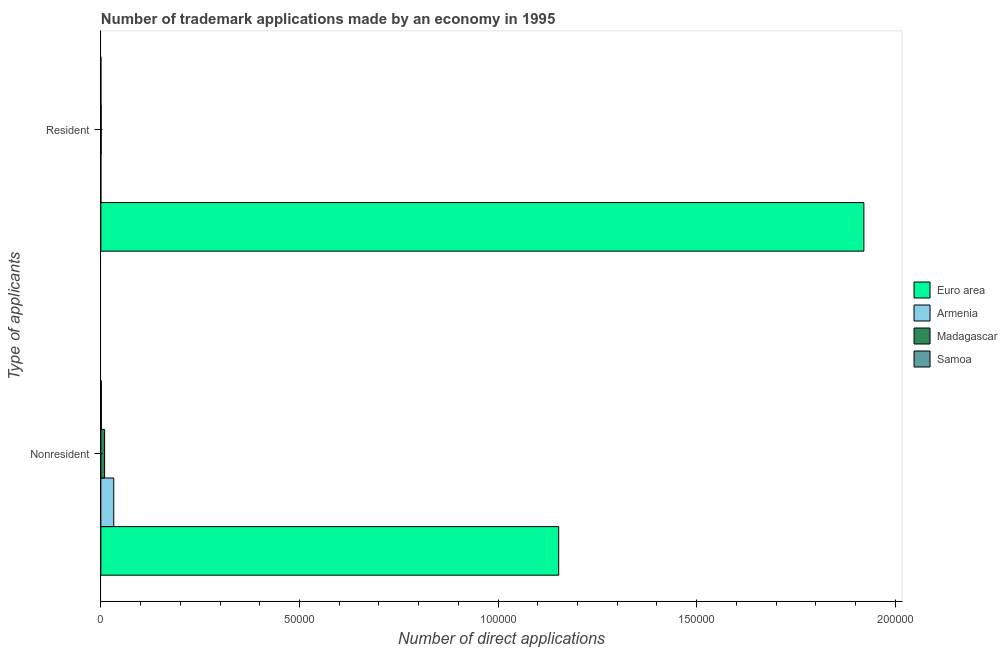Are the number of bars per tick equal to the number of legend labels?
Your response must be concise. Yes. How many bars are there on the 1st tick from the top?
Keep it short and to the point. 4. What is the label of the 2nd group of bars from the top?
Ensure brevity in your answer.  Nonresident. What is the number of trademark applications made by residents in Euro area?
Your answer should be very brief. 1.92e+05. Across all countries, what is the maximum number of trademark applications made by non residents?
Your answer should be very brief. 1.15e+05. Across all countries, what is the minimum number of trademark applications made by non residents?
Provide a short and direct response. 132. In which country was the number of trademark applications made by non residents maximum?
Your answer should be very brief. Euro area. In which country was the number of trademark applications made by residents minimum?
Provide a succinct answer. Armenia. What is the total number of trademark applications made by residents in the graph?
Offer a very short reply. 1.92e+05. What is the difference between the number of trademark applications made by non residents in Armenia and that in Madagascar?
Ensure brevity in your answer.  2294. What is the difference between the number of trademark applications made by residents in Madagascar and the number of trademark applications made by non residents in Samoa?
Give a very brief answer. -38. What is the average number of trademark applications made by non residents per country?
Keep it short and to the point. 2.99e+04. What is the difference between the number of trademark applications made by non residents and number of trademark applications made by residents in Samoa?
Make the answer very short. 120. In how many countries, is the number of trademark applications made by non residents greater than 30000 ?
Give a very brief answer. 1. What is the ratio of the number of trademark applications made by residents in Madagascar to that in Armenia?
Offer a terse response. 15.67. What does the 4th bar from the bottom in Nonresident represents?
Provide a succinct answer. Samoa. How many bars are there?
Offer a terse response. 8. Are all the bars in the graph horizontal?
Offer a terse response. Yes. How many countries are there in the graph?
Give a very brief answer. 4. What is the difference between two consecutive major ticks on the X-axis?
Offer a terse response. 5.00e+04. Where does the legend appear in the graph?
Your answer should be compact. Center right. How are the legend labels stacked?
Keep it short and to the point. Vertical. What is the title of the graph?
Keep it short and to the point. Number of trademark applications made by an economy in 1995. Does "Austria" appear as one of the legend labels in the graph?
Keep it short and to the point. No. What is the label or title of the X-axis?
Give a very brief answer. Number of direct applications. What is the label or title of the Y-axis?
Your answer should be very brief. Type of applicants. What is the Number of direct applications of Euro area in Nonresident?
Your answer should be very brief. 1.15e+05. What is the Number of direct applications in Armenia in Nonresident?
Keep it short and to the point. 3248. What is the Number of direct applications in Madagascar in Nonresident?
Ensure brevity in your answer.  954. What is the Number of direct applications in Samoa in Nonresident?
Provide a succinct answer. 132. What is the Number of direct applications of Euro area in Resident?
Give a very brief answer. 1.92e+05. What is the Number of direct applications in Armenia in Resident?
Your answer should be compact. 6. What is the Number of direct applications of Madagascar in Resident?
Your answer should be very brief. 94. What is the Number of direct applications in Samoa in Resident?
Make the answer very short. 12. Across all Type of applicants, what is the maximum Number of direct applications of Euro area?
Your answer should be compact. 1.92e+05. Across all Type of applicants, what is the maximum Number of direct applications in Armenia?
Provide a short and direct response. 3248. Across all Type of applicants, what is the maximum Number of direct applications of Madagascar?
Offer a very short reply. 954. Across all Type of applicants, what is the maximum Number of direct applications of Samoa?
Keep it short and to the point. 132. Across all Type of applicants, what is the minimum Number of direct applications of Euro area?
Give a very brief answer. 1.15e+05. Across all Type of applicants, what is the minimum Number of direct applications of Armenia?
Make the answer very short. 6. Across all Type of applicants, what is the minimum Number of direct applications of Madagascar?
Give a very brief answer. 94. What is the total Number of direct applications of Euro area in the graph?
Your answer should be compact. 3.07e+05. What is the total Number of direct applications in Armenia in the graph?
Give a very brief answer. 3254. What is the total Number of direct applications in Madagascar in the graph?
Offer a very short reply. 1048. What is the total Number of direct applications in Samoa in the graph?
Your answer should be very brief. 144. What is the difference between the Number of direct applications in Euro area in Nonresident and that in Resident?
Offer a very short reply. -7.68e+04. What is the difference between the Number of direct applications of Armenia in Nonresident and that in Resident?
Make the answer very short. 3242. What is the difference between the Number of direct applications of Madagascar in Nonresident and that in Resident?
Give a very brief answer. 860. What is the difference between the Number of direct applications of Samoa in Nonresident and that in Resident?
Your response must be concise. 120. What is the difference between the Number of direct applications in Euro area in Nonresident and the Number of direct applications in Armenia in Resident?
Provide a succinct answer. 1.15e+05. What is the difference between the Number of direct applications of Euro area in Nonresident and the Number of direct applications of Madagascar in Resident?
Provide a short and direct response. 1.15e+05. What is the difference between the Number of direct applications of Euro area in Nonresident and the Number of direct applications of Samoa in Resident?
Provide a succinct answer. 1.15e+05. What is the difference between the Number of direct applications of Armenia in Nonresident and the Number of direct applications of Madagascar in Resident?
Offer a terse response. 3154. What is the difference between the Number of direct applications of Armenia in Nonresident and the Number of direct applications of Samoa in Resident?
Provide a succinct answer. 3236. What is the difference between the Number of direct applications of Madagascar in Nonresident and the Number of direct applications of Samoa in Resident?
Ensure brevity in your answer.  942. What is the average Number of direct applications in Euro area per Type of applicants?
Give a very brief answer. 1.54e+05. What is the average Number of direct applications in Armenia per Type of applicants?
Provide a succinct answer. 1627. What is the average Number of direct applications in Madagascar per Type of applicants?
Give a very brief answer. 524. What is the average Number of direct applications of Samoa per Type of applicants?
Provide a short and direct response. 72. What is the difference between the Number of direct applications in Euro area and Number of direct applications in Armenia in Nonresident?
Your response must be concise. 1.12e+05. What is the difference between the Number of direct applications of Euro area and Number of direct applications of Madagascar in Nonresident?
Provide a short and direct response. 1.14e+05. What is the difference between the Number of direct applications in Euro area and Number of direct applications in Samoa in Nonresident?
Your response must be concise. 1.15e+05. What is the difference between the Number of direct applications in Armenia and Number of direct applications in Madagascar in Nonresident?
Keep it short and to the point. 2294. What is the difference between the Number of direct applications of Armenia and Number of direct applications of Samoa in Nonresident?
Your response must be concise. 3116. What is the difference between the Number of direct applications in Madagascar and Number of direct applications in Samoa in Nonresident?
Offer a terse response. 822. What is the difference between the Number of direct applications of Euro area and Number of direct applications of Armenia in Resident?
Provide a short and direct response. 1.92e+05. What is the difference between the Number of direct applications of Euro area and Number of direct applications of Madagascar in Resident?
Provide a short and direct response. 1.92e+05. What is the difference between the Number of direct applications in Euro area and Number of direct applications in Samoa in Resident?
Provide a succinct answer. 1.92e+05. What is the difference between the Number of direct applications in Armenia and Number of direct applications in Madagascar in Resident?
Your answer should be very brief. -88. What is the difference between the Number of direct applications in Armenia and Number of direct applications in Samoa in Resident?
Offer a very short reply. -6. What is the ratio of the Number of direct applications in Armenia in Nonresident to that in Resident?
Ensure brevity in your answer.  541.33. What is the ratio of the Number of direct applications in Madagascar in Nonresident to that in Resident?
Provide a short and direct response. 10.15. What is the difference between the highest and the second highest Number of direct applications in Euro area?
Offer a very short reply. 7.68e+04. What is the difference between the highest and the second highest Number of direct applications of Armenia?
Your answer should be compact. 3242. What is the difference between the highest and the second highest Number of direct applications of Madagascar?
Provide a succinct answer. 860. What is the difference between the highest and the second highest Number of direct applications in Samoa?
Keep it short and to the point. 120. What is the difference between the highest and the lowest Number of direct applications in Euro area?
Give a very brief answer. 7.68e+04. What is the difference between the highest and the lowest Number of direct applications in Armenia?
Make the answer very short. 3242. What is the difference between the highest and the lowest Number of direct applications in Madagascar?
Keep it short and to the point. 860. What is the difference between the highest and the lowest Number of direct applications of Samoa?
Provide a short and direct response. 120. 